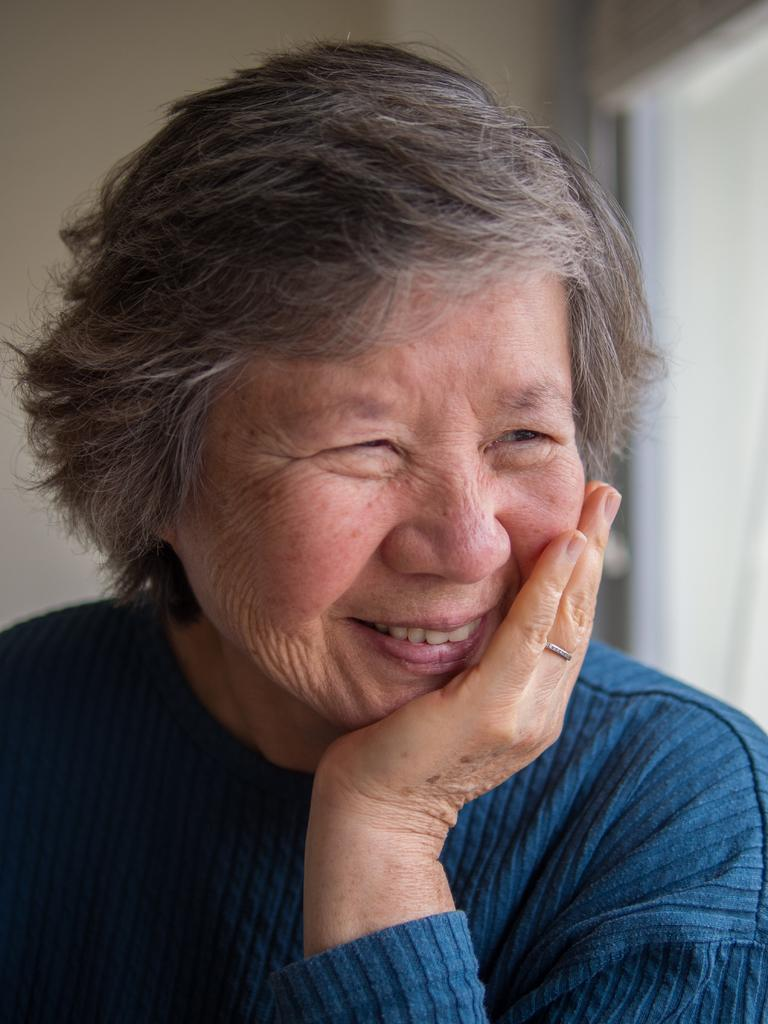Who is present in the image? There is a lady in the image. What is the lady doing in the image? The lady is smiling. Can you see the lady joining a game at the seashore in the image? There is no mention of a game or seashore in the image; it only shows a lady who is smiling. 